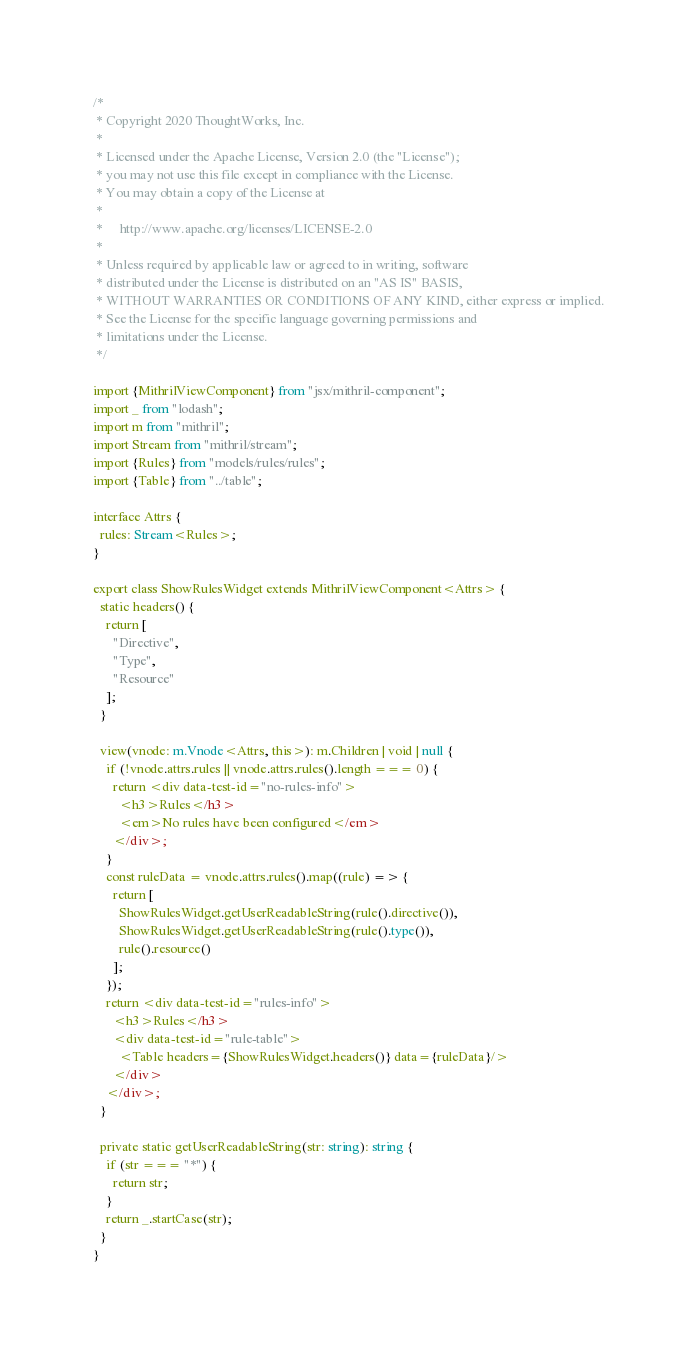Convert code to text. <code><loc_0><loc_0><loc_500><loc_500><_TypeScript_>/*
 * Copyright 2020 ThoughtWorks, Inc.
 *
 * Licensed under the Apache License, Version 2.0 (the "License");
 * you may not use this file except in compliance with the License.
 * You may obtain a copy of the License at
 *
 *     http://www.apache.org/licenses/LICENSE-2.0
 *
 * Unless required by applicable law or agreed to in writing, software
 * distributed under the License is distributed on an "AS IS" BASIS,
 * WITHOUT WARRANTIES OR CONDITIONS OF ANY KIND, either express or implied.
 * See the License for the specific language governing permissions and
 * limitations under the License.
 */

import {MithrilViewComponent} from "jsx/mithril-component";
import _ from "lodash";
import m from "mithril";
import Stream from "mithril/stream";
import {Rules} from "models/rules/rules";
import {Table} from "../table";

interface Attrs {
  rules: Stream<Rules>;
}

export class ShowRulesWidget extends MithrilViewComponent<Attrs> {
  static headers() {
    return [
      "Directive",
      "Type",
      "Resource"
    ];
  }

  view(vnode: m.Vnode<Attrs, this>): m.Children | void | null {
    if (!vnode.attrs.rules || vnode.attrs.rules().length === 0) {
      return <div data-test-id="no-rules-info">
        <h3>Rules</h3>
        <em>No rules have been configured</em>
      </div>;
    }
    const ruleData = vnode.attrs.rules().map((rule) => {
      return [
        ShowRulesWidget.getUserReadableString(rule().directive()),
        ShowRulesWidget.getUserReadableString(rule().type()),
        rule().resource()
      ];
    });
    return <div data-test-id="rules-info">
      <h3>Rules</h3>
      <div data-test-id="rule-table">
        <Table headers={ShowRulesWidget.headers()} data={ruleData}/>
      </div>
    </div>;
  }

  private static getUserReadableString(str: string): string {
    if (str === "*") {
      return str;
    }
    return _.startCase(str);
  }
}
</code> 